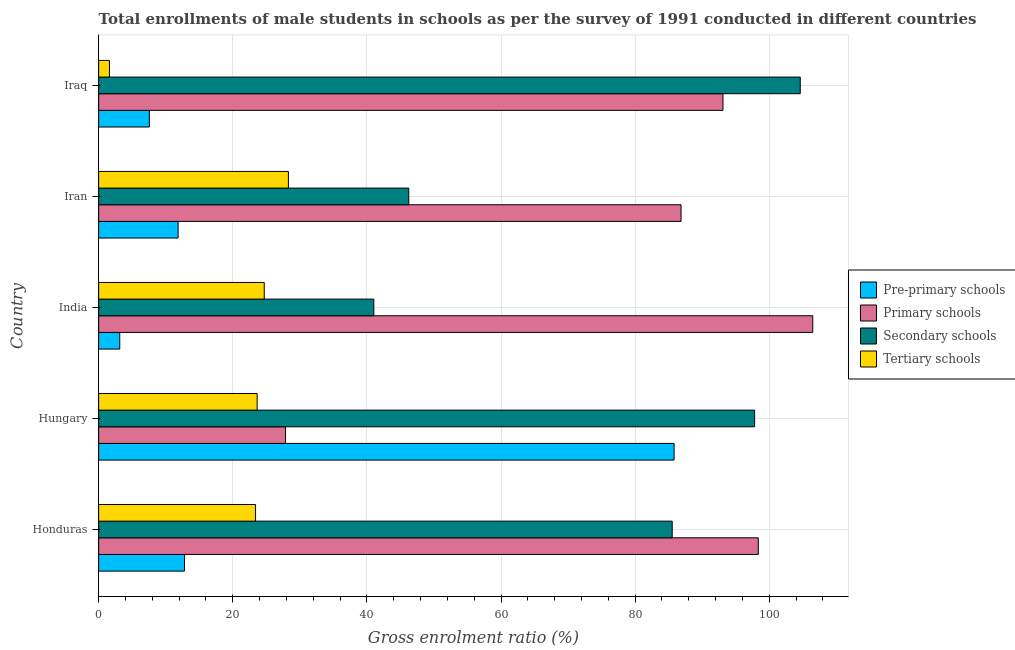How many groups of bars are there?
Ensure brevity in your answer.  5. How many bars are there on the 1st tick from the bottom?
Provide a short and direct response. 4. What is the label of the 4th group of bars from the top?
Your response must be concise. Hungary. In how many cases, is the number of bars for a given country not equal to the number of legend labels?
Your answer should be very brief. 0. What is the gross enrolment ratio(male) in pre-primary schools in Iraq?
Give a very brief answer. 7.56. Across all countries, what is the maximum gross enrolment ratio(male) in pre-primary schools?
Ensure brevity in your answer.  85.81. Across all countries, what is the minimum gross enrolment ratio(male) in pre-primary schools?
Your answer should be compact. 3.15. In which country was the gross enrolment ratio(male) in tertiary schools maximum?
Give a very brief answer. Iran. What is the total gross enrolment ratio(male) in primary schools in the graph?
Provide a short and direct response. 412.68. What is the difference between the gross enrolment ratio(male) in primary schools in Hungary and that in Iraq?
Provide a succinct answer. -65.23. What is the difference between the gross enrolment ratio(male) in pre-primary schools in Hungary and the gross enrolment ratio(male) in tertiary schools in Honduras?
Ensure brevity in your answer.  62.41. What is the average gross enrolment ratio(male) in tertiary schools per country?
Offer a very short reply. 20.33. What is the difference between the gross enrolment ratio(male) in pre-primary schools and gross enrolment ratio(male) in secondary schools in India?
Give a very brief answer. -37.89. In how many countries, is the gross enrolment ratio(male) in tertiary schools greater than 32 %?
Offer a very short reply. 0. What is the ratio of the gross enrolment ratio(male) in tertiary schools in Hungary to that in Iran?
Your answer should be very brief. 0.83. Is the difference between the gross enrolment ratio(male) in pre-primary schools in India and Iran greater than the difference between the gross enrolment ratio(male) in primary schools in India and Iran?
Provide a succinct answer. No. What is the difference between the highest and the second highest gross enrolment ratio(male) in pre-primary schools?
Keep it short and to the point. 73.01. What is the difference between the highest and the lowest gross enrolment ratio(male) in primary schools?
Your answer should be compact. 78.62. Is the sum of the gross enrolment ratio(male) in secondary schools in Honduras and India greater than the maximum gross enrolment ratio(male) in tertiary schools across all countries?
Offer a terse response. Yes. What does the 3rd bar from the top in Hungary represents?
Make the answer very short. Primary schools. What does the 4th bar from the bottom in Iraq represents?
Your answer should be very brief. Tertiary schools. Is it the case that in every country, the sum of the gross enrolment ratio(male) in pre-primary schools and gross enrolment ratio(male) in primary schools is greater than the gross enrolment ratio(male) in secondary schools?
Make the answer very short. No. How many bars are there?
Ensure brevity in your answer.  20. Are all the bars in the graph horizontal?
Ensure brevity in your answer.  Yes. How many countries are there in the graph?
Provide a succinct answer. 5. Where does the legend appear in the graph?
Offer a very short reply. Center right. How are the legend labels stacked?
Give a very brief answer. Vertical. What is the title of the graph?
Provide a short and direct response. Total enrollments of male students in schools as per the survey of 1991 conducted in different countries. Does "HFC gas" appear as one of the legend labels in the graph?
Keep it short and to the point. No. What is the label or title of the X-axis?
Provide a succinct answer. Gross enrolment ratio (%). What is the Gross enrolment ratio (%) in Pre-primary schools in Honduras?
Your response must be concise. 12.81. What is the Gross enrolment ratio (%) in Primary schools in Honduras?
Provide a short and direct response. 98.36. What is the Gross enrolment ratio (%) in Secondary schools in Honduras?
Provide a succinct answer. 85.53. What is the Gross enrolment ratio (%) in Tertiary schools in Honduras?
Your response must be concise. 23.4. What is the Gross enrolment ratio (%) in Pre-primary schools in Hungary?
Ensure brevity in your answer.  85.81. What is the Gross enrolment ratio (%) of Primary schools in Hungary?
Keep it short and to the point. 27.87. What is the Gross enrolment ratio (%) of Secondary schools in Hungary?
Your response must be concise. 97.82. What is the Gross enrolment ratio (%) in Tertiary schools in Hungary?
Provide a short and direct response. 23.64. What is the Gross enrolment ratio (%) of Pre-primary schools in India?
Provide a succinct answer. 3.15. What is the Gross enrolment ratio (%) of Primary schools in India?
Give a very brief answer. 106.49. What is the Gross enrolment ratio (%) of Secondary schools in India?
Offer a terse response. 41.04. What is the Gross enrolment ratio (%) of Tertiary schools in India?
Offer a terse response. 24.7. What is the Gross enrolment ratio (%) of Pre-primary schools in Iran?
Provide a succinct answer. 11.85. What is the Gross enrolment ratio (%) of Primary schools in Iran?
Offer a terse response. 86.85. What is the Gross enrolment ratio (%) of Secondary schools in Iran?
Provide a succinct answer. 46.25. What is the Gross enrolment ratio (%) in Tertiary schools in Iran?
Offer a terse response. 28.3. What is the Gross enrolment ratio (%) of Pre-primary schools in Iraq?
Your response must be concise. 7.56. What is the Gross enrolment ratio (%) in Primary schools in Iraq?
Ensure brevity in your answer.  93.1. What is the Gross enrolment ratio (%) of Secondary schools in Iraq?
Your response must be concise. 104.62. What is the Gross enrolment ratio (%) of Tertiary schools in Iraq?
Your response must be concise. 1.62. Across all countries, what is the maximum Gross enrolment ratio (%) of Pre-primary schools?
Offer a very short reply. 85.81. Across all countries, what is the maximum Gross enrolment ratio (%) in Primary schools?
Keep it short and to the point. 106.49. Across all countries, what is the maximum Gross enrolment ratio (%) in Secondary schools?
Keep it short and to the point. 104.62. Across all countries, what is the maximum Gross enrolment ratio (%) of Tertiary schools?
Offer a very short reply. 28.3. Across all countries, what is the minimum Gross enrolment ratio (%) of Pre-primary schools?
Provide a succinct answer. 3.15. Across all countries, what is the minimum Gross enrolment ratio (%) of Primary schools?
Your answer should be very brief. 27.87. Across all countries, what is the minimum Gross enrolment ratio (%) in Secondary schools?
Provide a short and direct response. 41.04. Across all countries, what is the minimum Gross enrolment ratio (%) of Tertiary schools?
Provide a succinct answer. 1.62. What is the total Gross enrolment ratio (%) in Pre-primary schools in the graph?
Your answer should be very brief. 121.18. What is the total Gross enrolment ratio (%) of Primary schools in the graph?
Offer a terse response. 412.68. What is the total Gross enrolment ratio (%) of Secondary schools in the graph?
Provide a succinct answer. 375.25. What is the total Gross enrolment ratio (%) in Tertiary schools in the graph?
Provide a short and direct response. 101.64. What is the difference between the Gross enrolment ratio (%) in Pre-primary schools in Honduras and that in Hungary?
Offer a terse response. -73.01. What is the difference between the Gross enrolment ratio (%) of Primary schools in Honduras and that in Hungary?
Your answer should be very brief. 70.49. What is the difference between the Gross enrolment ratio (%) in Secondary schools in Honduras and that in Hungary?
Your response must be concise. -12.29. What is the difference between the Gross enrolment ratio (%) in Tertiary schools in Honduras and that in Hungary?
Your answer should be very brief. -0.24. What is the difference between the Gross enrolment ratio (%) in Pre-primary schools in Honduras and that in India?
Your answer should be very brief. 9.66. What is the difference between the Gross enrolment ratio (%) of Primary schools in Honduras and that in India?
Provide a short and direct response. -8.13. What is the difference between the Gross enrolment ratio (%) in Secondary schools in Honduras and that in India?
Offer a very short reply. 44.49. What is the difference between the Gross enrolment ratio (%) of Tertiary schools in Honduras and that in India?
Provide a short and direct response. -1.3. What is the difference between the Gross enrolment ratio (%) in Pre-primary schools in Honduras and that in Iran?
Ensure brevity in your answer.  0.96. What is the difference between the Gross enrolment ratio (%) of Primary schools in Honduras and that in Iran?
Your response must be concise. 11.52. What is the difference between the Gross enrolment ratio (%) of Secondary schools in Honduras and that in Iran?
Your answer should be very brief. 39.28. What is the difference between the Gross enrolment ratio (%) in Tertiary schools in Honduras and that in Iran?
Your answer should be compact. -4.9. What is the difference between the Gross enrolment ratio (%) in Pre-primary schools in Honduras and that in Iraq?
Your response must be concise. 5.24. What is the difference between the Gross enrolment ratio (%) in Primary schools in Honduras and that in Iraq?
Provide a short and direct response. 5.26. What is the difference between the Gross enrolment ratio (%) of Secondary schools in Honduras and that in Iraq?
Offer a terse response. -19.09. What is the difference between the Gross enrolment ratio (%) of Tertiary schools in Honduras and that in Iraq?
Offer a very short reply. 21.78. What is the difference between the Gross enrolment ratio (%) of Pre-primary schools in Hungary and that in India?
Provide a succinct answer. 82.66. What is the difference between the Gross enrolment ratio (%) in Primary schools in Hungary and that in India?
Offer a terse response. -78.62. What is the difference between the Gross enrolment ratio (%) in Secondary schools in Hungary and that in India?
Give a very brief answer. 56.78. What is the difference between the Gross enrolment ratio (%) of Tertiary schools in Hungary and that in India?
Provide a short and direct response. -1.06. What is the difference between the Gross enrolment ratio (%) in Pre-primary schools in Hungary and that in Iran?
Give a very brief answer. 73.96. What is the difference between the Gross enrolment ratio (%) in Primary schools in Hungary and that in Iran?
Provide a short and direct response. -58.98. What is the difference between the Gross enrolment ratio (%) in Secondary schools in Hungary and that in Iran?
Provide a succinct answer. 51.57. What is the difference between the Gross enrolment ratio (%) of Tertiary schools in Hungary and that in Iran?
Keep it short and to the point. -4.66. What is the difference between the Gross enrolment ratio (%) in Pre-primary schools in Hungary and that in Iraq?
Your response must be concise. 78.25. What is the difference between the Gross enrolment ratio (%) of Primary schools in Hungary and that in Iraq?
Keep it short and to the point. -65.23. What is the difference between the Gross enrolment ratio (%) in Secondary schools in Hungary and that in Iraq?
Your answer should be compact. -6.8. What is the difference between the Gross enrolment ratio (%) in Tertiary schools in Hungary and that in Iraq?
Offer a very short reply. 22.02. What is the difference between the Gross enrolment ratio (%) in Pre-primary schools in India and that in Iran?
Offer a terse response. -8.7. What is the difference between the Gross enrolment ratio (%) of Primary schools in India and that in Iran?
Provide a short and direct response. 19.64. What is the difference between the Gross enrolment ratio (%) of Secondary schools in India and that in Iran?
Ensure brevity in your answer.  -5.21. What is the difference between the Gross enrolment ratio (%) in Tertiary schools in India and that in Iran?
Provide a short and direct response. -3.6. What is the difference between the Gross enrolment ratio (%) in Pre-primary schools in India and that in Iraq?
Your response must be concise. -4.41. What is the difference between the Gross enrolment ratio (%) of Primary schools in India and that in Iraq?
Offer a terse response. 13.39. What is the difference between the Gross enrolment ratio (%) of Secondary schools in India and that in Iraq?
Give a very brief answer. -63.59. What is the difference between the Gross enrolment ratio (%) in Tertiary schools in India and that in Iraq?
Your answer should be very brief. 23.08. What is the difference between the Gross enrolment ratio (%) in Pre-primary schools in Iran and that in Iraq?
Offer a terse response. 4.28. What is the difference between the Gross enrolment ratio (%) of Primary schools in Iran and that in Iraq?
Your response must be concise. -6.25. What is the difference between the Gross enrolment ratio (%) of Secondary schools in Iran and that in Iraq?
Provide a succinct answer. -58.38. What is the difference between the Gross enrolment ratio (%) in Tertiary schools in Iran and that in Iraq?
Keep it short and to the point. 26.68. What is the difference between the Gross enrolment ratio (%) of Pre-primary schools in Honduras and the Gross enrolment ratio (%) of Primary schools in Hungary?
Your answer should be compact. -15.07. What is the difference between the Gross enrolment ratio (%) in Pre-primary schools in Honduras and the Gross enrolment ratio (%) in Secondary schools in Hungary?
Give a very brief answer. -85.01. What is the difference between the Gross enrolment ratio (%) in Pre-primary schools in Honduras and the Gross enrolment ratio (%) in Tertiary schools in Hungary?
Offer a terse response. -10.83. What is the difference between the Gross enrolment ratio (%) in Primary schools in Honduras and the Gross enrolment ratio (%) in Secondary schools in Hungary?
Provide a short and direct response. 0.54. What is the difference between the Gross enrolment ratio (%) in Primary schools in Honduras and the Gross enrolment ratio (%) in Tertiary schools in Hungary?
Your response must be concise. 74.73. What is the difference between the Gross enrolment ratio (%) of Secondary schools in Honduras and the Gross enrolment ratio (%) of Tertiary schools in Hungary?
Provide a succinct answer. 61.89. What is the difference between the Gross enrolment ratio (%) in Pre-primary schools in Honduras and the Gross enrolment ratio (%) in Primary schools in India?
Provide a short and direct response. -93.68. What is the difference between the Gross enrolment ratio (%) of Pre-primary schools in Honduras and the Gross enrolment ratio (%) of Secondary schools in India?
Keep it short and to the point. -28.23. What is the difference between the Gross enrolment ratio (%) of Pre-primary schools in Honduras and the Gross enrolment ratio (%) of Tertiary schools in India?
Make the answer very short. -11.89. What is the difference between the Gross enrolment ratio (%) in Primary schools in Honduras and the Gross enrolment ratio (%) in Secondary schools in India?
Provide a succinct answer. 57.33. What is the difference between the Gross enrolment ratio (%) in Primary schools in Honduras and the Gross enrolment ratio (%) in Tertiary schools in India?
Offer a terse response. 73.67. What is the difference between the Gross enrolment ratio (%) of Secondary schools in Honduras and the Gross enrolment ratio (%) of Tertiary schools in India?
Make the answer very short. 60.83. What is the difference between the Gross enrolment ratio (%) in Pre-primary schools in Honduras and the Gross enrolment ratio (%) in Primary schools in Iran?
Give a very brief answer. -74.04. What is the difference between the Gross enrolment ratio (%) in Pre-primary schools in Honduras and the Gross enrolment ratio (%) in Secondary schools in Iran?
Provide a short and direct response. -33.44. What is the difference between the Gross enrolment ratio (%) of Pre-primary schools in Honduras and the Gross enrolment ratio (%) of Tertiary schools in Iran?
Ensure brevity in your answer.  -15.49. What is the difference between the Gross enrolment ratio (%) in Primary schools in Honduras and the Gross enrolment ratio (%) in Secondary schools in Iran?
Offer a very short reply. 52.12. What is the difference between the Gross enrolment ratio (%) of Primary schools in Honduras and the Gross enrolment ratio (%) of Tertiary schools in Iran?
Offer a very short reply. 70.07. What is the difference between the Gross enrolment ratio (%) of Secondary schools in Honduras and the Gross enrolment ratio (%) of Tertiary schools in Iran?
Your response must be concise. 57.23. What is the difference between the Gross enrolment ratio (%) of Pre-primary schools in Honduras and the Gross enrolment ratio (%) of Primary schools in Iraq?
Offer a terse response. -80.3. What is the difference between the Gross enrolment ratio (%) in Pre-primary schools in Honduras and the Gross enrolment ratio (%) in Secondary schools in Iraq?
Your response must be concise. -91.82. What is the difference between the Gross enrolment ratio (%) of Pre-primary schools in Honduras and the Gross enrolment ratio (%) of Tertiary schools in Iraq?
Provide a succinct answer. 11.19. What is the difference between the Gross enrolment ratio (%) of Primary schools in Honduras and the Gross enrolment ratio (%) of Secondary schools in Iraq?
Make the answer very short. -6.26. What is the difference between the Gross enrolment ratio (%) of Primary schools in Honduras and the Gross enrolment ratio (%) of Tertiary schools in Iraq?
Your response must be concise. 96.75. What is the difference between the Gross enrolment ratio (%) of Secondary schools in Honduras and the Gross enrolment ratio (%) of Tertiary schools in Iraq?
Make the answer very short. 83.91. What is the difference between the Gross enrolment ratio (%) of Pre-primary schools in Hungary and the Gross enrolment ratio (%) of Primary schools in India?
Your answer should be compact. -20.68. What is the difference between the Gross enrolment ratio (%) of Pre-primary schools in Hungary and the Gross enrolment ratio (%) of Secondary schools in India?
Keep it short and to the point. 44.78. What is the difference between the Gross enrolment ratio (%) of Pre-primary schools in Hungary and the Gross enrolment ratio (%) of Tertiary schools in India?
Make the answer very short. 61.12. What is the difference between the Gross enrolment ratio (%) of Primary schools in Hungary and the Gross enrolment ratio (%) of Secondary schools in India?
Make the answer very short. -13.16. What is the difference between the Gross enrolment ratio (%) in Primary schools in Hungary and the Gross enrolment ratio (%) in Tertiary schools in India?
Give a very brief answer. 3.18. What is the difference between the Gross enrolment ratio (%) of Secondary schools in Hungary and the Gross enrolment ratio (%) of Tertiary schools in India?
Provide a short and direct response. 73.12. What is the difference between the Gross enrolment ratio (%) of Pre-primary schools in Hungary and the Gross enrolment ratio (%) of Primary schools in Iran?
Offer a terse response. -1.04. What is the difference between the Gross enrolment ratio (%) of Pre-primary schools in Hungary and the Gross enrolment ratio (%) of Secondary schools in Iran?
Make the answer very short. 39.56. What is the difference between the Gross enrolment ratio (%) in Pre-primary schools in Hungary and the Gross enrolment ratio (%) in Tertiary schools in Iran?
Offer a very short reply. 57.51. What is the difference between the Gross enrolment ratio (%) of Primary schools in Hungary and the Gross enrolment ratio (%) of Secondary schools in Iran?
Make the answer very short. -18.38. What is the difference between the Gross enrolment ratio (%) in Primary schools in Hungary and the Gross enrolment ratio (%) in Tertiary schools in Iran?
Provide a short and direct response. -0.43. What is the difference between the Gross enrolment ratio (%) of Secondary schools in Hungary and the Gross enrolment ratio (%) of Tertiary schools in Iran?
Make the answer very short. 69.52. What is the difference between the Gross enrolment ratio (%) of Pre-primary schools in Hungary and the Gross enrolment ratio (%) of Primary schools in Iraq?
Your answer should be very brief. -7.29. What is the difference between the Gross enrolment ratio (%) in Pre-primary schools in Hungary and the Gross enrolment ratio (%) in Secondary schools in Iraq?
Offer a very short reply. -18.81. What is the difference between the Gross enrolment ratio (%) of Pre-primary schools in Hungary and the Gross enrolment ratio (%) of Tertiary schools in Iraq?
Offer a terse response. 84.19. What is the difference between the Gross enrolment ratio (%) in Primary schools in Hungary and the Gross enrolment ratio (%) in Secondary schools in Iraq?
Offer a very short reply. -76.75. What is the difference between the Gross enrolment ratio (%) in Primary schools in Hungary and the Gross enrolment ratio (%) in Tertiary schools in Iraq?
Offer a terse response. 26.25. What is the difference between the Gross enrolment ratio (%) in Secondary schools in Hungary and the Gross enrolment ratio (%) in Tertiary schools in Iraq?
Your answer should be very brief. 96.2. What is the difference between the Gross enrolment ratio (%) in Pre-primary schools in India and the Gross enrolment ratio (%) in Primary schools in Iran?
Your answer should be compact. -83.7. What is the difference between the Gross enrolment ratio (%) of Pre-primary schools in India and the Gross enrolment ratio (%) of Secondary schools in Iran?
Offer a very short reply. -43.1. What is the difference between the Gross enrolment ratio (%) in Pre-primary schools in India and the Gross enrolment ratio (%) in Tertiary schools in Iran?
Provide a succinct answer. -25.15. What is the difference between the Gross enrolment ratio (%) of Primary schools in India and the Gross enrolment ratio (%) of Secondary schools in Iran?
Give a very brief answer. 60.24. What is the difference between the Gross enrolment ratio (%) in Primary schools in India and the Gross enrolment ratio (%) in Tertiary schools in Iran?
Keep it short and to the point. 78.19. What is the difference between the Gross enrolment ratio (%) of Secondary schools in India and the Gross enrolment ratio (%) of Tertiary schools in Iran?
Ensure brevity in your answer.  12.74. What is the difference between the Gross enrolment ratio (%) of Pre-primary schools in India and the Gross enrolment ratio (%) of Primary schools in Iraq?
Provide a succinct answer. -89.95. What is the difference between the Gross enrolment ratio (%) in Pre-primary schools in India and the Gross enrolment ratio (%) in Secondary schools in Iraq?
Offer a very short reply. -101.47. What is the difference between the Gross enrolment ratio (%) in Pre-primary schools in India and the Gross enrolment ratio (%) in Tertiary schools in Iraq?
Keep it short and to the point. 1.53. What is the difference between the Gross enrolment ratio (%) of Primary schools in India and the Gross enrolment ratio (%) of Secondary schools in Iraq?
Make the answer very short. 1.87. What is the difference between the Gross enrolment ratio (%) in Primary schools in India and the Gross enrolment ratio (%) in Tertiary schools in Iraq?
Your response must be concise. 104.87. What is the difference between the Gross enrolment ratio (%) of Secondary schools in India and the Gross enrolment ratio (%) of Tertiary schools in Iraq?
Keep it short and to the point. 39.42. What is the difference between the Gross enrolment ratio (%) in Pre-primary schools in Iran and the Gross enrolment ratio (%) in Primary schools in Iraq?
Offer a terse response. -81.25. What is the difference between the Gross enrolment ratio (%) of Pre-primary schools in Iran and the Gross enrolment ratio (%) of Secondary schools in Iraq?
Offer a terse response. -92.78. What is the difference between the Gross enrolment ratio (%) in Pre-primary schools in Iran and the Gross enrolment ratio (%) in Tertiary schools in Iraq?
Ensure brevity in your answer.  10.23. What is the difference between the Gross enrolment ratio (%) in Primary schools in Iran and the Gross enrolment ratio (%) in Secondary schools in Iraq?
Your answer should be compact. -17.77. What is the difference between the Gross enrolment ratio (%) in Primary schools in Iran and the Gross enrolment ratio (%) in Tertiary schools in Iraq?
Provide a short and direct response. 85.23. What is the difference between the Gross enrolment ratio (%) of Secondary schools in Iran and the Gross enrolment ratio (%) of Tertiary schools in Iraq?
Your response must be concise. 44.63. What is the average Gross enrolment ratio (%) of Pre-primary schools per country?
Keep it short and to the point. 24.24. What is the average Gross enrolment ratio (%) in Primary schools per country?
Ensure brevity in your answer.  82.53. What is the average Gross enrolment ratio (%) in Secondary schools per country?
Provide a short and direct response. 75.05. What is the average Gross enrolment ratio (%) of Tertiary schools per country?
Provide a short and direct response. 20.33. What is the difference between the Gross enrolment ratio (%) of Pre-primary schools and Gross enrolment ratio (%) of Primary schools in Honduras?
Keep it short and to the point. -85.56. What is the difference between the Gross enrolment ratio (%) of Pre-primary schools and Gross enrolment ratio (%) of Secondary schools in Honduras?
Make the answer very short. -72.72. What is the difference between the Gross enrolment ratio (%) of Pre-primary schools and Gross enrolment ratio (%) of Tertiary schools in Honduras?
Give a very brief answer. -10.59. What is the difference between the Gross enrolment ratio (%) of Primary schools and Gross enrolment ratio (%) of Secondary schools in Honduras?
Offer a terse response. 12.84. What is the difference between the Gross enrolment ratio (%) of Primary schools and Gross enrolment ratio (%) of Tertiary schools in Honduras?
Offer a terse response. 74.97. What is the difference between the Gross enrolment ratio (%) of Secondary schools and Gross enrolment ratio (%) of Tertiary schools in Honduras?
Offer a terse response. 62.13. What is the difference between the Gross enrolment ratio (%) in Pre-primary schools and Gross enrolment ratio (%) in Primary schools in Hungary?
Give a very brief answer. 57.94. What is the difference between the Gross enrolment ratio (%) in Pre-primary schools and Gross enrolment ratio (%) in Secondary schools in Hungary?
Ensure brevity in your answer.  -12.01. What is the difference between the Gross enrolment ratio (%) in Pre-primary schools and Gross enrolment ratio (%) in Tertiary schools in Hungary?
Your answer should be compact. 62.18. What is the difference between the Gross enrolment ratio (%) in Primary schools and Gross enrolment ratio (%) in Secondary schools in Hungary?
Offer a terse response. -69.95. What is the difference between the Gross enrolment ratio (%) in Primary schools and Gross enrolment ratio (%) in Tertiary schools in Hungary?
Give a very brief answer. 4.24. What is the difference between the Gross enrolment ratio (%) of Secondary schools and Gross enrolment ratio (%) of Tertiary schools in Hungary?
Keep it short and to the point. 74.18. What is the difference between the Gross enrolment ratio (%) of Pre-primary schools and Gross enrolment ratio (%) of Primary schools in India?
Keep it short and to the point. -103.34. What is the difference between the Gross enrolment ratio (%) of Pre-primary schools and Gross enrolment ratio (%) of Secondary schools in India?
Provide a short and direct response. -37.89. What is the difference between the Gross enrolment ratio (%) in Pre-primary schools and Gross enrolment ratio (%) in Tertiary schools in India?
Your answer should be very brief. -21.55. What is the difference between the Gross enrolment ratio (%) of Primary schools and Gross enrolment ratio (%) of Secondary schools in India?
Your response must be concise. 65.45. What is the difference between the Gross enrolment ratio (%) in Primary schools and Gross enrolment ratio (%) in Tertiary schools in India?
Provide a succinct answer. 81.79. What is the difference between the Gross enrolment ratio (%) of Secondary schools and Gross enrolment ratio (%) of Tertiary schools in India?
Offer a terse response. 16.34. What is the difference between the Gross enrolment ratio (%) of Pre-primary schools and Gross enrolment ratio (%) of Primary schools in Iran?
Provide a short and direct response. -75. What is the difference between the Gross enrolment ratio (%) of Pre-primary schools and Gross enrolment ratio (%) of Secondary schools in Iran?
Offer a very short reply. -34.4. What is the difference between the Gross enrolment ratio (%) in Pre-primary schools and Gross enrolment ratio (%) in Tertiary schools in Iran?
Make the answer very short. -16.45. What is the difference between the Gross enrolment ratio (%) of Primary schools and Gross enrolment ratio (%) of Secondary schools in Iran?
Your response must be concise. 40.6. What is the difference between the Gross enrolment ratio (%) of Primary schools and Gross enrolment ratio (%) of Tertiary schools in Iran?
Give a very brief answer. 58.55. What is the difference between the Gross enrolment ratio (%) of Secondary schools and Gross enrolment ratio (%) of Tertiary schools in Iran?
Give a very brief answer. 17.95. What is the difference between the Gross enrolment ratio (%) of Pre-primary schools and Gross enrolment ratio (%) of Primary schools in Iraq?
Keep it short and to the point. -85.54. What is the difference between the Gross enrolment ratio (%) of Pre-primary schools and Gross enrolment ratio (%) of Secondary schools in Iraq?
Provide a short and direct response. -97.06. What is the difference between the Gross enrolment ratio (%) of Pre-primary schools and Gross enrolment ratio (%) of Tertiary schools in Iraq?
Your answer should be compact. 5.95. What is the difference between the Gross enrolment ratio (%) of Primary schools and Gross enrolment ratio (%) of Secondary schools in Iraq?
Offer a terse response. -11.52. What is the difference between the Gross enrolment ratio (%) in Primary schools and Gross enrolment ratio (%) in Tertiary schools in Iraq?
Give a very brief answer. 91.48. What is the difference between the Gross enrolment ratio (%) of Secondary schools and Gross enrolment ratio (%) of Tertiary schools in Iraq?
Ensure brevity in your answer.  103.01. What is the ratio of the Gross enrolment ratio (%) of Pre-primary schools in Honduras to that in Hungary?
Your response must be concise. 0.15. What is the ratio of the Gross enrolment ratio (%) of Primary schools in Honduras to that in Hungary?
Provide a succinct answer. 3.53. What is the ratio of the Gross enrolment ratio (%) of Secondary schools in Honduras to that in Hungary?
Offer a terse response. 0.87. What is the ratio of the Gross enrolment ratio (%) in Pre-primary schools in Honduras to that in India?
Offer a terse response. 4.07. What is the ratio of the Gross enrolment ratio (%) of Primary schools in Honduras to that in India?
Keep it short and to the point. 0.92. What is the ratio of the Gross enrolment ratio (%) in Secondary schools in Honduras to that in India?
Keep it short and to the point. 2.08. What is the ratio of the Gross enrolment ratio (%) in Tertiary schools in Honduras to that in India?
Your answer should be very brief. 0.95. What is the ratio of the Gross enrolment ratio (%) of Pre-primary schools in Honduras to that in Iran?
Offer a terse response. 1.08. What is the ratio of the Gross enrolment ratio (%) in Primary schools in Honduras to that in Iran?
Provide a short and direct response. 1.13. What is the ratio of the Gross enrolment ratio (%) in Secondary schools in Honduras to that in Iran?
Ensure brevity in your answer.  1.85. What is the ratio of the Gross enrolment ratio (%) in Tertiary schools in Honduras to that in Iran?
Keep it short and to the point. 0.83. What is the ratio of the Gross enrolment ratio (%) in Pre-primary schools in Honduras to that in Iraq?
Keep it short and to the point. 1.69. What is the ratio of the Gross enrolment ratio (%) of Primary schools in Honduras to that in Iraq?
Offer a very short reply. 1.06. What is the ratio of the Gross enrolment ratio (%) of Secondary schools in Honduras to that in Iraq?
Your answer should be very brief. 0.82. What is the ratio of the Gross enrolment ratio (%) in Tertiary schools in Honduras to that in Iraq?
Provide a succinct answer. 14.47. What is the ratio of the Gross enrolment ratio (%) in Pre-primary schools in Hungary to that in India?
Keep it short and to the point. 27.26. What is the ratio of the Gross enrolment ratio (%) of Primary schools in Hungary to that in India?
Your answer should be compact. 0.26. What is the ratio of the Gross enrolment ratio (%) of Secondary schools in Hungary to that in India?
Offer a terse response. 2.38. What is the ratio of the Gross enrolment ratio (%) in Tertiary schools in Hungary to that in India?
Your answer should be very brief. 0.96. What is the ratio of the Gross enrolment ratio (%) of Pre-primary schools in Hungary to that in Iran?
Keep it short and to the point. 7.24. What is the ratio of the Gross enrolment ratio (%) in Primary schools in Hungary to that in Iran?
Offer a terse response. 0.32. What is the ratio of the Gross enrolment ratio (%) in Secondary schools in Hungary to that in Iran?
Ensure brevity in your answer.  2.12. What is the ratio of the Gross enrolment ratio (%) in Tertiary schools in Hungary to that in Iran?
Ensure brevity in your answer.  0.84. What is the ratio of the Gross enrolment ratio (%) in Pre-primary schools in Hungary to that in Iraq?
Your answer should be very brief. 11.35. What is the ratio of the Gross enrolment ratio (%) in Primary schools in Hungary to that in Iraq?
Your answer should be very brief. 0.3. What is the ratio of the Gross enrolment ratio (%) of Secondary schools in Hungary to that in Iraq?
Give a very brief answer. 0.94. What is the ratio of the Gross enrolment ratio (%) in Tertiary schools in Hungary to that in Iraq?
Give a very brief answer. 14.62. What is the ratio of the Gross enrolment ratio (%) in Pre-primary schools in India to that in Iran?
Offer a terse response. 0.27. What is the ratio of the Gross enrolment ratio (%) in Primary schools in India to that in Iran?
Ensure brevity in your answer.  1.23. What is the ratio of the Gross enrolment ratio (%) in Secondary schools in India to that in Iran?
Your answer should be very brief. 0.89. What is the ratio of the Gross enrolment ratio (%) in Tertiary schools in India to that in Iran?
Provide a short and direct response. 0.87. What is the ratio of the Gross enrolment ratio (%) of Pre-primary schools in India to that in Iraq?
Your response must be concise. 0.42. What is the ratio of the Gross enrolment ratio (%) of Primary schools in India to that in Iraq?
Ensure brevity in your answer.  1.14. What is the ratio of the Gross enrolment ratio (%) in Secondary schools in India to that in Iraq?
Your response must be concise. 0.39. What is the ratio of the Gross enrolment ratio (%) of Tertiary schools in India to that in Iraq?
Ensure brevity in your answer.  15.27. What is the ratio of the Gross enrolment ratio (%) of Pre-primary schools in Iran to that in Iraq?
Provide a short and direct response. 1.57. What is the ratio of the Gross enrolment ratio (%) of Primary schools in Iran to that in Iraq?
Your answer should be very brief. 0.93. What is the ratio of the Gross enrolment ratio (%) of Secondary schools in Iran to that in Iraq?
Your response must be concise. 0.44. What is the ratio of the Gross enrolment ratio (%) of Tertiary schools in Iran to that in Iraq?
Your answer should be compact. 17.5. What is the difference between the highest and the second highest Gross enrolment ratio (%) in Pre-primary schools?
Provide a short and direct response. 73.01. What is the difference between the highest and the second highest Gross enrolment ratio (%) of Primary schools?
Your response must be concise. 8.13. What is the difference between the highest and the second highest Gross enrolment ratio (%) in Secondary schools?
Provide a succinct answer. 6.8. What is the difference between the highest and the second highest Gross enrolment ratio (%) of Tertiary schools?
Make the answer very short. 3.6. What is the difference between the highest and the lowest Gross enrolment ratio (%) of Pre-primary schools?
Your response must be concise. 82.66. What is the difference between the highest and the lowest Gross enrolment ratio (%) of Primary schools?
Offer a terse response. 78.62. What is the difference between the highest and the lowest Gross enrolment ratio (%) in Secondary schools?
Give a very brief answer. 63.59. What is the difference between the highest and the lowest Gross enrolment ratio (%) in Tertiary schools?
Your answer should be very brief. 26.68. 